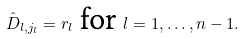Convert formula to latex. <formula><loc_0><loc_0><loc_500><loc_500>\hat { D } _ { l , j _ { l } } = r _ { l } \text { for } l = 1 , \dots , n - 1 .</formula> 